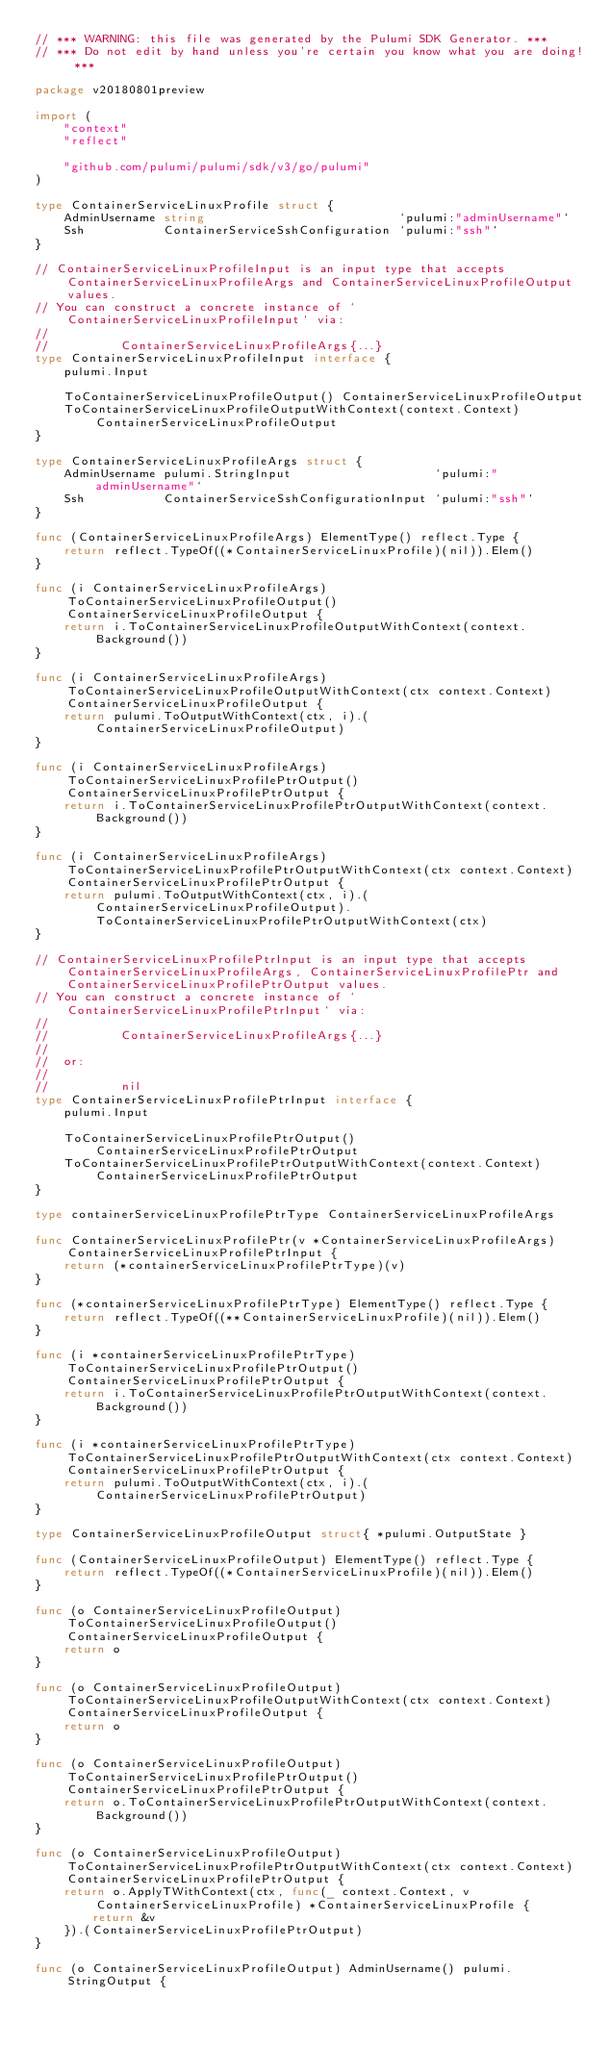<code> <loc_0><loc_0><loc_500><loc_500><_Go_>// *** WARNING: this file was generated by the Pulumi SDK Generator. ***
// *** Do not edit by hand unless you're certain you know what you are doing! ***

package v20180801preview

import (
	"context"
	"reflect"

	"github.com/pulumi/pulumi/sdk/v3/go/pulumi"
)

type ContainerServiceLinuxProfile struct {
	AdminUsername string                           `pulumi:"adminUsername"`
	Ssh           ContainerServiceSshConfiguration `pulumi:"ssh"`
}

// ContainerServiceLinuxProfileInput is an input type that accepts ContainerServiceLinuxProfileArgs and ContainerServiceLinuxProfileOutput values.
// You can construct a concrete instance of `ContainerServiceLinuxProfileInput` via:
//
//          ContainerServiceLinuxProfileArgs{...}
type ContainerServiceLinuxProfileInput interface {
	pulumi.Input

	ToContainerServiceLinuxProfileOutput() ContainerServiceLinuxProfileOutput
	ToContainerServiceLinuxProfileOutputWithContext(context.Context) ContainerServiceLinuxProfileOutput
}

type ContainerServiceLinuxProfileArgs struct {
	AdminUsername pulumi.StringInput                    `pulumi:"adminUsername"`
	Ssh           ContainerServiceSshConfigurationInput `pulumi:"ssh"`
}

func (ContainerServiceLinuxProfileArgs) ElementType() reflect.Type {
	return reflect.TypeOf((*ContainerServiceLinuxProfile)(nil)).Elem()
}

func (i ContainerServiceLinuxProfileArgs) ToContainerServiceLinuxProfileOutput() ContainerServiceLinuxProfileOutput {
	return i.ToContainerServiceLinuxProfileOutputWithContext(context.Background())
}

func (i ContainerServiceLinuxProfileArgs) ToContainerServiceLinuxProfileOutputWithContext(ctx context.Context) ContainerServiceLinuxProfileOutput {
	return pulumi.ToOutputWithContext(ctx, i).(ContainerServiceLinuxProfileOutput)
}

func (i ContainerServiceLinuxProfileArgs) ToContainerServiceLinuxProfilePtrOutput() ContainerServiceLinuxProfilePtrOutput {
	return i.ToContainerServiceLinuxProfilePtrOutputWithContext(context.Background())
}

func (i ContainerServiceLinuxProfileArgs) ToContainerServiceLinuxProfilePtrOutputWithContext(ctx context.Context) ContainerServiceLinuxProfilePtrOutput {
	return pulumi.ToOutputWithContext(ctx, i).(ContainerServiceLinuxProfileOutput).ToContainerServiceLinuxProfilePtrOutputWithContext(ctx)
}

// ContainerServiceLinuxProfilePtrInput is an input type that accepts ContainerServiceLinuxProfileArgs, ContainerServiceLinuxProfilePtr and ContainerServiceLinuxProfilePtrOutput values.
// You can construct a concrete instance of `ContainerServiceLinuxProfilePtrInput` via:
//
//          ContainerServiceLinuxProfileArgs{...}
//
//  or:
//
//          nil
type ContainerServiceLinuxProfilePtrInput interface {
	pulumi.Input

	ToContainerServiceLinuxProfilePtrOutput() ContainerServiceLinuxProfilePtrOutput
	ToContainerServiceLinuxProfilePtrOutputWithContext(context.Context) ContainerServiceLinuxProfilePtrOutput
}

type containerServiceLinuxProfilePtrType ContainerServiceLinuxProfileArgs

func ContainerServiceLinuxProfilePtr(v *ContainerServiceLinuxProfileArgs) ContainerServiceLinuxProfilePtrInput {
	return (*containerServiceLinuxProfilePtrType)(v)
}

func (*containerServiceLinuxProfilePtrType) ElementType() reflect.Type {
	return reflect.TypeOf((**ContainerServiceLinuxProfile)(nil)).Elem()
}

func (i *containerServiceLinuxProfilePtrType) ToContainerServiceLinuxProfilePtrOutput() ContainerServiceLinuxProfilePtrOutput {
	return i.ToContainerServiceLinuxProfilePtrOutputWithContext(context.Background())
}

func (i *containerServiceLinuxProfilePtrType) ToContainerServiceLinuxProfilePtrOutputWithContext(ctx context.Context) ContainerServiceLinuxProfilePtrOutput {
	return pulumi.ToOutputWithContext(ctx, i).(ContainerServiceLinuxProfilePtrOutput)
}

type ContainerServiceLinuxProfileOutput struct{ *pulumi.OutputState }

func (ContainerServiceLinuxProfileOutput) ElementType() reflect.Type {
	return reflect.TypeOf((*ContainerServiceLinuxProfile)(nil)).Elem()
}

func (o ContainerServiceLinuxProfileOutput) ToContainerServiceLinuxProfileOutput() ContainerServiceLinuxProfileOutput {
	return o
}

func (o ContainerServiceLinuxProfileOutput) ToContainerServiceLinuxProfileOutputWithContext(ctx context.Context) ContainerServiceLinuxProfileOutput {
	return o
}

func (o ContainerServiceLinuxProfileOutput) ToContainerServiceLinuxProfilePtrOutput() ContainerServiceLinuxProfilePtrOutput {
	return o.ToContainerServiceLinuxProfilePtrOutputWithContext(context.Background())
}

func (o ContainerServiceLinuxProfileOutput) ToContainerServiceLinuxProfilePtrOutputWithContext(ctx context.Context) ContainerServiceLinuxProfilePtrOutput {
	return o.ApplyTWithContext(ctx, func(_ context.Context, v ContainerServiceLinuxProfile) *ContainerServiceLinuxProfile {
		return &v
	}).(ContainerServiceLinuxProfilePtrOutput)
}

func (o ContainerServiceLinuxProfileOutput) AdminUsername() pulumi.StringOutput {</code> 